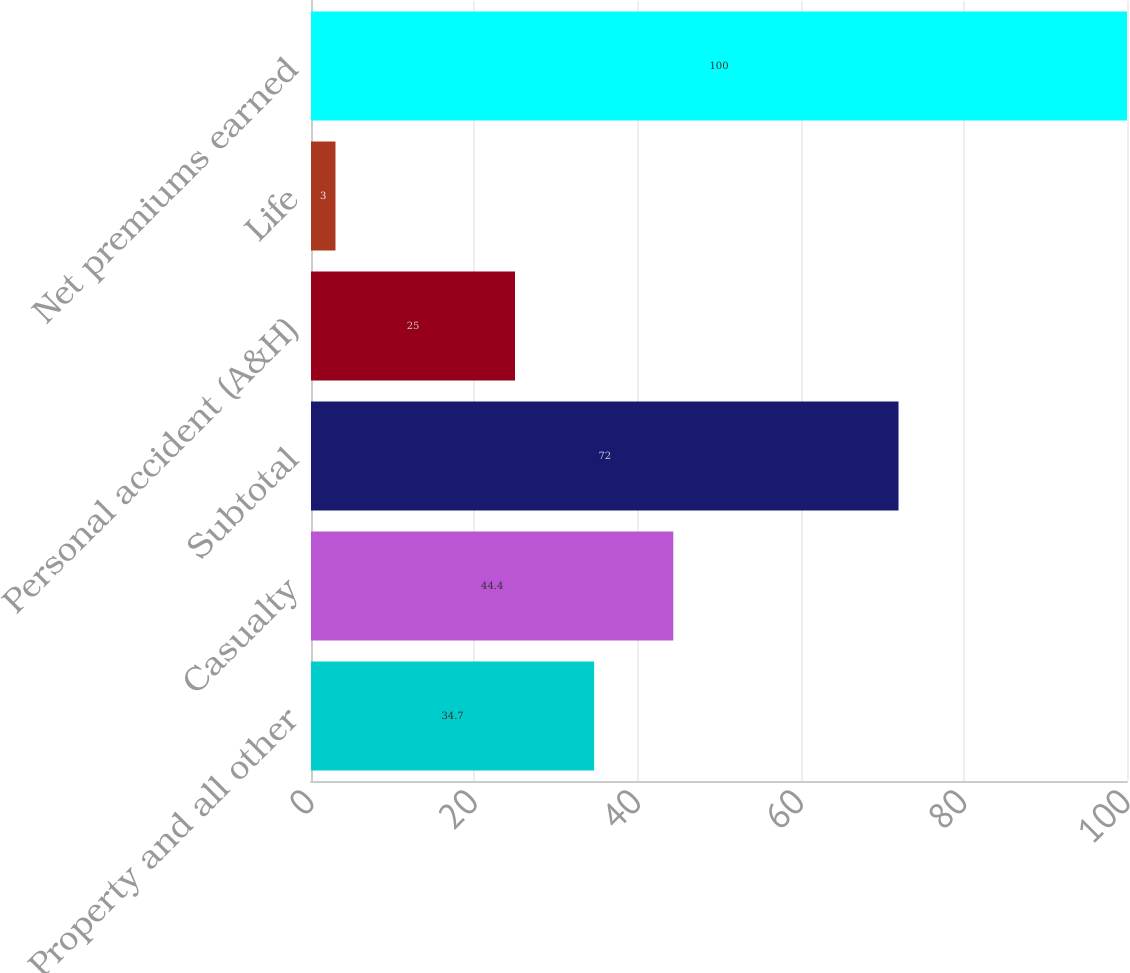Convert chart to OTSL. <chart><loc_0><loc_0><loc_500><loc_500><bar_chart><fcel>Property and all other<fcel>Casualty<fcel>Subtotal<fcel>Personal accident (A&H)<fcel>Life<fcel>Net premiums earned<nl><fcel>34.7<fcel>44.4<fcel>72<fcel>25<fcel>3<fcel>100<nl></chart> 